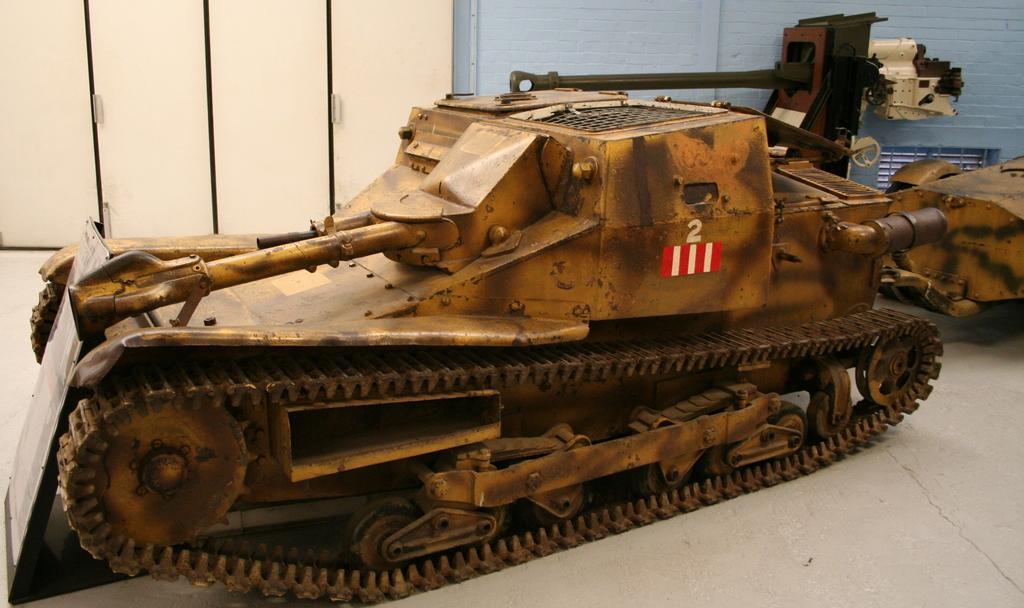Describe this image in one or two sentences. In the picture I can see vehicles on the floor. In the background I can see doors and wall. 